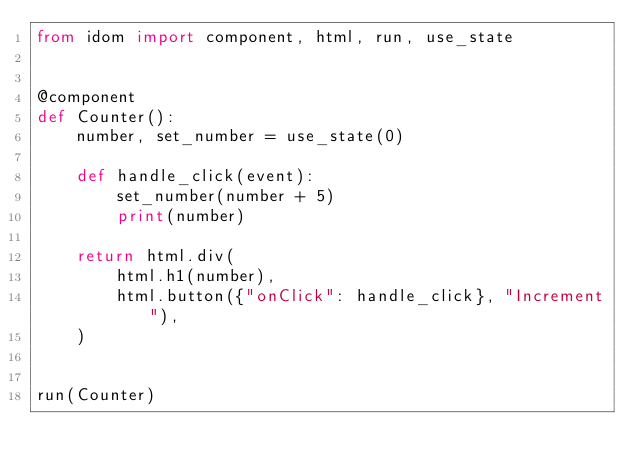Convert code to text. <code><loc_0><loc_0><loc_500><loc_500><_Python_>from idom import component, html, run, use_state


@component
def Counter():
    number, set_number = use_state(0)

    def handle_click(event):
        set_number(number + 5)
        print(number)

    return html.div(
        html.h1(number),
        html.button({"onClick": handle_click}, "Increment"),
    )


run(Counter)
</code> 